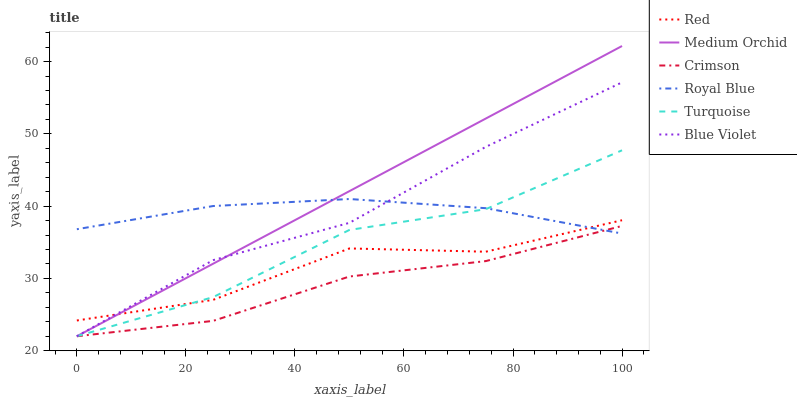Does Crimson have the minimum area under the curve?
Answer yes or no. Yes. Does Medium Orchid have the maximum area under the curve?
Answer yes or no. Yes. Does Royal Blue have the minimum area under the curve?
Answer yes or no. No. Does Royal Blue have the maximum area under the curve?
Answer yes or no. No. Is Medium Orchid the smoothest?
Answer yes or no. Yes. Is Red the roughest?
Answer yes or no. Yes. Is Royal Blue the smoothest?
Answer yes or no. No. Is Royal Blue the roughest?
Answer yes or no. No. Does Turquoise have the lowest value?
Answer yes or no. Yes. Does Royal Blue have the lowest value?
Answer yes or no. No. Does Medium Orchid have the highest value?
Answer yes or no. Yes. Does Royal Blue have the highest value?
Answer yes or no. No. Is Crimson less than Red?
Answer yes or no. Yes. Is Red greater than Crimson?
Answer yes or no. Yes. Does Turquoise intersect Blue Violet?
Answer yes or no. Yes. Is Turquoise less than Blue Violet?
Answer yes or no. No. Is Turquoise greater than Blue Violet?
Answer yes or no. No. Does Crimson intersect Red?
Answer yes or no. No. 